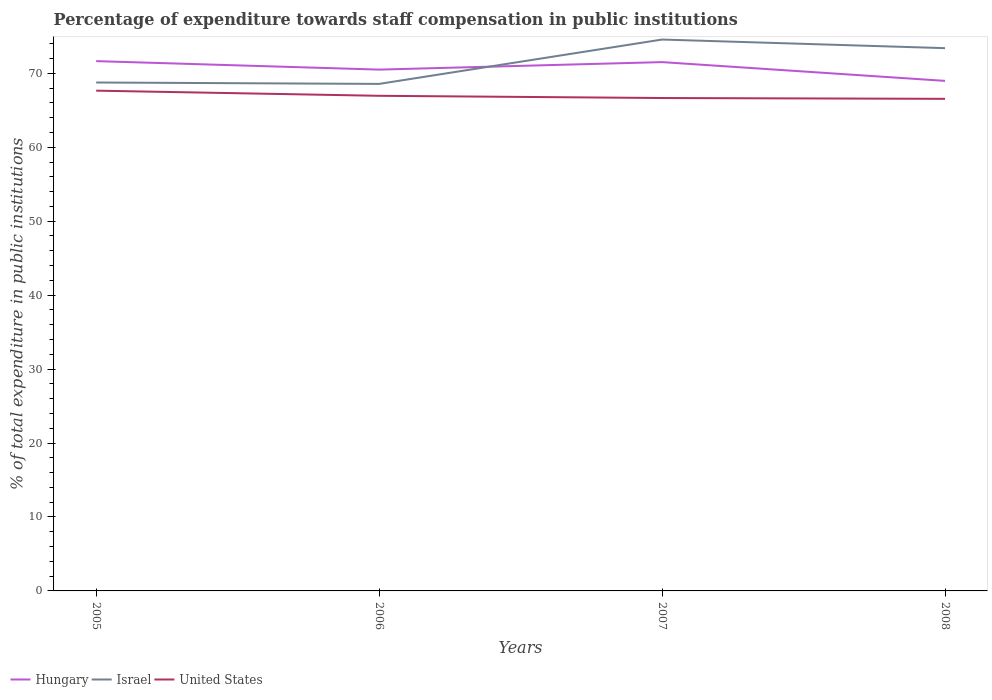How many different coloured lines are there?
Provide a short and direct response. 3. Across all years, what is the maximum percentage of expenditure towards staff compensation in Hungary?
Provide a succinct answer. 68.97. In which year was the percentage of expenditure towards staff compensation in Israel maximum?
Your response must be concise. 2006. What is the total percentage of expenditure towards staff compensation in United States in the graph?
Your answer should be compact. 1. What is the difference between the highest and the second highest percentage of expenditure towards staff compensation in Hungary?
Your answer should be very brief. 2.67. How many years are there in the graph?
Make the answer very short. 4. Does the graph contain any zero values?
Provide a short and direct response. No. How are the legend labels stacked?
Make the answer very short. Horizontal. What is the title of the graph?
Provide a succinct answer. Percentage of expenditure towards staff compensation in public institutions. What is the label or title of the Y-axis?
Ensure brevity in your answer.  % of total expenditure in public institutions. What is the % of total expenditure in public institutions in Hungary in 2005?
Your answer should be very brief. 71.64. What is the % of total expenditure in public institutions of Israel in 2005?
Your response must be concise. 68.75. What is the % of total expenditure in public institutions in United States in 2005?
Keep it short and to the point. 67.65. What is the % of total expenditure in public institutions of Hungary in 2006?
Make the answer very short. 70.49. What is the % of total expenditure in public institutions of Israel in 2006?
Provide a succinct answer. 68.56. What is the % of total expenditure in public institutions of United States in 2006?
Your response must be concise. 66.95. What is the % of total expenditure in public institutions of Hungary in 2007?
Offer a very short reply. 71.51. What is the % of total expenditure in public institutions of Israel in 2007?
Offer a terse response. 74.56. What is the % of total expenditure in public institutions in United States in 2007?
Provide a short and direct response. 66.65. What is the % of total expenditure in public institutions of Hungary in 2008?
Your response must be concise. 68.97. What is the % of total expenditure in public institutions of Israel in 2008?
Offer a very short reply. 73.4. What is the % of total expenditure in public institutions of United States in 2008?
Keep it short and to the point. 66.54. Across all years, what is the maximum % of total expenditure in public institutions in Hungary?
Give a very brief answer. 71.64. Across all years, what is the maximum % of total expenditure in public institutions in Israel?
Provide a short and direct response. 74.56. Across all years, what is the maximum % of total expenditure in public institutions of United States?
Your answer should be compact. 67.65. Across all years, what is the minimum % of total expenditure in public institutions of Hungary?
Offer a very short reply. 68.97. Across all years, what is the minimum % of total expenditure in public institutions of Israel?
Your response must be concise. 68.56. Across all years, what is the minimum % of total expenditure in public institutions in United States?
Offer a very short reply. 66.54. What is the total % of total expenditure in public institutions in Hungary in the graph?
Your response must be concise. 282.62. What is the total % of total expenditure in public institutions of Israel in the graph?
Provide a short and direct response. 285.27. What is the total % of total expenditure in public institutions of United States in the graph?
Your answer should be very brief. 267.8. What is the difference between the % of total expenditure in public institutions of Hungary in 2005 and that in 2006?
Your response must be concise. 1.15. What is the difference between the % of total expenditure in public institutions of Israel in 2005 and that in 2006?
Your answer should be compact. 0.19. What is the difference between the % of total expenditure in public institutions of United States in 2005 and that in 2006?
Provide a succinct answer. 0.7. What is the difference between the % of total expenditure in public institutions in Hungary in 2005 and that in 2007?
Offer a very short reply. 0.13. What is the difference between the % of total expenditure in public institutions in Israel in 2005 and that in 2007?
Provide a short and direct response. -5.81. What is the difference between the % of total expenditure in public institutions in United States in 2005 and that in 2007?
Offer a very short reply. 1. What is the difference between the % of total expenditure in public institutions in Hungary in 2005 and that in 2008?
Give a very brief answer. 2.67. What is the difference between the % of total expenditure in public institutions of Israel in 2005 and that in 2008?
Your answer should be compact. -4.65. What is the difference between the % of total expenditure in public institutions of United States in 2005 and that in 2008?
Give a very brief answer. 1.11. What is the difference between the % of total expenditure in public institutions in Hungary in 2006 and that in 2007?
Your answer should be very brief. -1.01. What is the difference between the % of total expenditure in public institutions of Israel in 2006 and that in 2007?
Provide a succinct answer. -6. What is the difference between the % of total expenditure in public institutions in United States in 2006 and that in 2007?
Your answer should be compact. 0.3. What is the difference between the % of total expenditure in public institutions in Hungary in 2006 and that in 2008?
Make the answer very short. 1.52. What is the difference between the % of total expenditure in public institutions in Israel in 2006 and that in 2008?
Provide a succinct answer. -4.83. What is the difference between the % of total expenditure in public institutions in United States in 2006 and that in 2008?
Provide a short and direct response. 0.41. What is the difference between the % of total expenditure in public institutions in Hungary in 2007 and that in 2008?
Your answer should be very brief. 2.54. What is the difference between the % of total expenditure in public institutions of Israel in 2007 and that in 2008?
Offer a very short reply. 1.16. What is the difference between the % of total expenditure in public institutions of United States in 2007 and that in 2008?
Keep it short and to the point. 0.11. What is the difference between the % of total expenditure in public institutions in Hungary in 2005 and the % of total expenditure in public institutions in Israel in 2006?
Make the answer very short. 3.08. What is the difference between the % of total expenditure in public institutions in Hungary in 2005 and the % of total expenditure in public institutions in United States in 2006?
Keep it short and to the point. 4.69. What is the difference between the % of total expenditure in public institutions of Israel in 2005 and the % of total expenditure in public institutions of United States in 2006?
Offer a terse response. 1.8. What is the difference between the % of total expenditure in public institutions of Hungary in 2005 and the % of total expenditure in public institutions of Israel in 2007?
Your response must be concise. -2.92. What is the difference between the % of total expenditure in public institutions in Hungary in 2005 and the % of total expenditure in public institutions in United States in 2007?
Ensure brevity in your answer.  4.99. What is the difference between the % of total expenditure in public institutions of Israel in 2005 and the % of total expenditure in public institutions of United States in 2007?
Offer a terse response. 2.1. What is the difference between the % of total expenditure in public institutions of Hungary in 2005 and the % of total expenditure in public institutions of Israel in 2008?
Provide a short and direct response. -1.75. What is the difference between the % of total expenditure in public institutions of Hungary in 2005 and the % of total expenditure in public institutions of United States in 2008?
Ensure brevity in your answer.  5.1. What is the difference between the % of total expenditure in public institutions of Israel in 2005 and the % of total expenditure in public institutions of United States in 2008?
Make the answer very short. 2.21. What is the difference between the % of total expenditure in public institutions in Hungary in 2006 and the % of total expenditure in public institutions in Israel in 2007?
Your answer should be very brief. -4.07. What is the difference between the % of total expenditure in public institutions of Hungary in 2006 and the % of total expenditure in public institutions of United States in 2007?
Your response must be concise. 3.84. What is the difference between the % of total expenditure in public institutions of Israel in 2006 and the % of total expenditure in public institutions of United States in 2007?
Your response must be concise. 1.91. What is the difference between the % of total expenditure in public institutions of Hungary in 2006 and the % of total expenditure in public institutions of Israel in 2008?
Offer a very short reply. -2.9. What is the difference between the % of total expenditure in public institutions in Hungary in 2006 and the % of total expenditure in public institutions in United States in 2008?
Offer a very short reply. 3.95. What is the difference between the % of total expenditure in public institutions of Israel in 2006 and the % of total expenditure in public institutions of United States in 2008?
Provide a short and direct response. 2.02. What is the difference between the % of total expenditure in public institutions in Hungary in 2007 and the % of total expenditure in public institutions in Israel in 2008?
Offer a terse response. -1.89. What is the difference between the % of total expenditure in public institutions of Hungary in 2007 and the % of total expenditure in public institutions of United States in 2008?
Make the answer very short. 4.96. What is the difference between the % of total expenditure in public institutions of Israel in 2007 and the % of total expenditure in public institutions of United States in 2008?
Provide a short and direct response. 8.02. What is the average % of total expenditure in public institutions in Hungary per year?
Make the answer very short. 70.65. What is the average % of total expenditure in public institutions of Israel per year?
Offer a very short reply. 71.32. What is the average % of total expenditure in public institutions in United States per year?
Offer a very short reply. 66.95. In the year 2005, what is the difference between the % of total expenditure in public institutions of Hungary and % of total expenditure in public institutions of Israel?
Offer a terse response. 2.89. In the year 2005, what is the difference between the % of total expenditure in public institutions in Hungary and % of total expenditure in public institutions in United States?
Provide a succinct answer. 3.99. In the year 2005, what is the difference between the % of total expenditure in public institutions in Israel and % of total expenditure in public institutions in United States?
Keep it short and to the point. 1.1. In the year 2006, what is the difference between the % of total expenditure in public institutions in Hungary and % of total expenditure in public institutions in Israel?
Provide a short and direct response. 1.93. In the year 2006, what is the difference between the % of total expenditure in public institutions of Hungary and % of total expenditure in public institutions of United States?
Ensure brevity in your answer.  3.54. In the year 2006, what is the difference between the % of total expenditure in public institutions in Israel and % of total expenditure in public institutions in United States?
Your response must be concise. 1.61. In the year 2007, what is the difference between the % of total expenditure in public institutions of Hungary and % of total expenditure in public institutions of Israel?
Offer a terse response. -3.05. In the year 2007, what is the difference between the % of total expenditure in public institutions of Hungary and % of total expenditure in public institutions of United States?
Your answer should be very brief. 4.85. In the year 2007, what is the difference between the % of total expenditure in public institutions in Israel and % of total expenditure in public institutions in United States?
Ensure brevity in your answer.  7.91. In the year 2008, what is the difference between the % of total expenditure in public institutions in Hungary and % of total expenditure in public institutions in Israel?
Offer a terse response. -4.43. In the year 2008, what is the difference between the % of total expenditure in public institutions in Hungary and % of total expenditure in public institutions in United States?
Offer a very short reply. 2.43. In the year 2008, what is the difference between the % of total expenditure in public institutions in Israel and % of total expenditure in public institutions in United States?
Offer a very short reply. 6.85. What is the ratio of the % of total expenditure in public institutions in Hungary in 2005 to that in 2006?
Your answer should be compact. 1.02. What is the ratio of the % of total expenditure in public institutions of United States in 2005 to that in 2006?
Your answer should be compact. 1.01. What is the ratio of the % of total expenditure in public institutions of Israel in 2005 to that in 2007?
Give a very brief answer. 0.92. What is the ratio of the % of total expenditure in public institutions of United States in 2005 to that in 2007?
Your answer should be compact. 1.01. What is the ratio of the % of total expenditure in public institutions in Hungary in 2005 to that in 2008?
Offer a very short reply. 1.04. What is the ratio of the % of total expenditure in public institutions of Israel in 2005 to that in 2008?
Your response must be concise. 0.94. What is the ratio of the % of total expenditure in public institutions in United States in 2005 to that in 2008?
Offer a very short reply. 1.02. What is the ratio of the % of total expenditure in public institutions in Hungary in 2006 to that in 2007?
Give a very brief answer. 0.99. What is the ratio of the % of total expenditure in public institutions of Israel in 2006 to that in 2007?
Your answer should be very brief. 0.92. What is the ratio of the % of total expenditure in public institutions in Hungary in 2006 to that in 2008?
Your response must be concise. 1.02. What is the ratio of the % of total expenditure in public institutions of Israel in 2006 to that in 2008?
Offer a very short reply. 0.93. What is the ratio of the % of total expenditure in public institutions of United States in 2006 to that in 2008?
Ensure brevity in your answer.  1.01. What is the ratio of the % of total expenditure in public institutions of Hungary in 2007 to that in 2008?
Your answer should be very brief. 1.04. What is the ratio of the % of total expenditure in public institutions of Israel in 2007 to that in 2008?
Keep it short and to the point. 1.02. What is the ratio of the % of total expenditure in public institutions of United States in 2007 to that in 2008?
Give a very brief answer. 1. What is the difference between the highest and the second highest % of total expenditure in public institutions of Hungary?
Ensure brevity in your answer.  0.13. What is the difference between the highest and the second highest % of total expenditure in public institutions in Israel?
Ensure brevity in your answer.  1.16. What is the difference between the highest and the second highest % of total expenditure in public institutions in United States?
Offer a very short reply. 0.7. What is the difference between the highest and the lowest % of total expenditure in public institutions in Hungary?
Offer a terse response. 2.67. What is the difference between the highest and the lowest % of total expenditure in public institutions in Israel?
Ensure brevity in your answer.  6. What is the difference between the highest and the lowest % of total expenditure in public institutions in United States?
Make the answer very short. 1.11. 